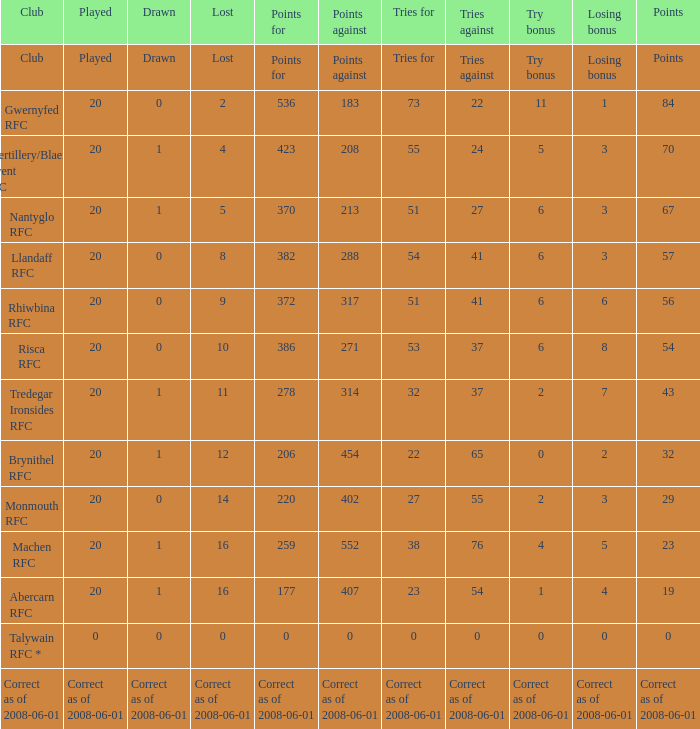When the points were 0, what was the bonus for the losing team? 0.0. 